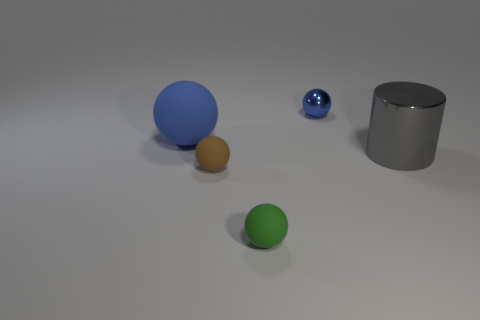What textures can be observed on the objects and the surface? The objects themselves seem to have smooth surfaces with varying degrees of reflectivity, while the surface upon which they rest appears to have a slight texture, almost like a fine grain, which can be particularly observed in the shadow regions. 